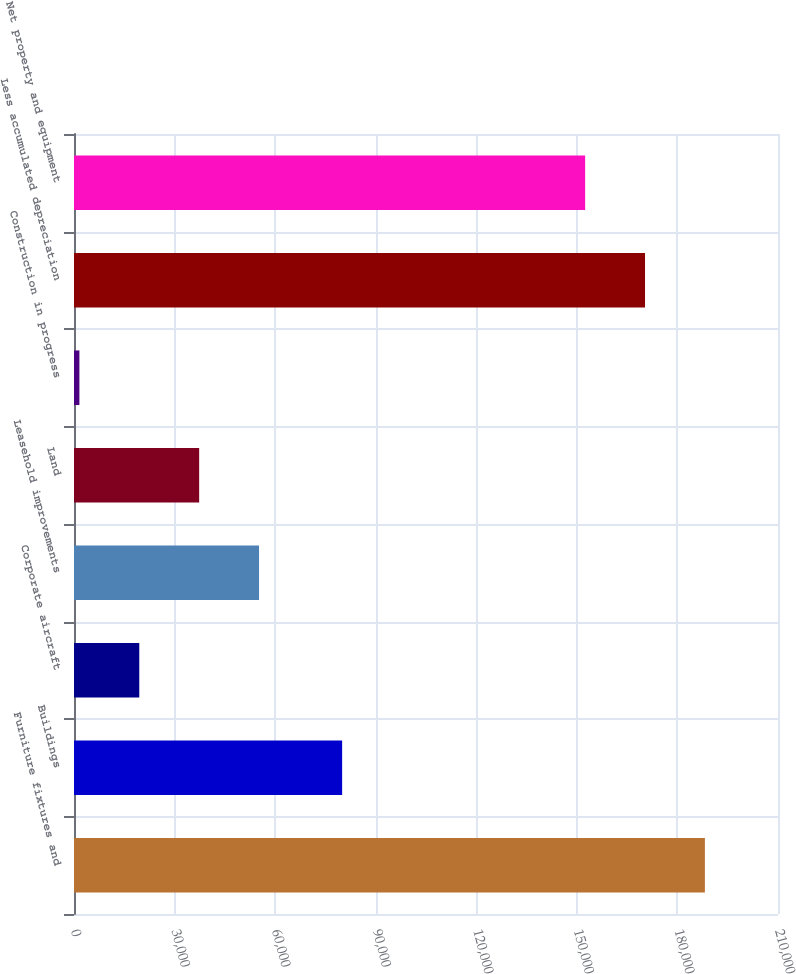<chart> <loc_0><loc_0><loc_500><loc_500><bar_chart><fcel>Furniture fixtures and<fcel>Buildings<fcel>Corporate aircraft<fcel>Leasehold improvements<fcel>Land<fcel>Construction in progress<fcel>Less accumulated depreciation<fcel>Net property and equipment<nl><fcel>188195<fcel>79981<fcel>19474.1<fcel>55198.3<fcel>37336.2<fcel>1612<fcel>170333<fcel>152471<nl></chart> 